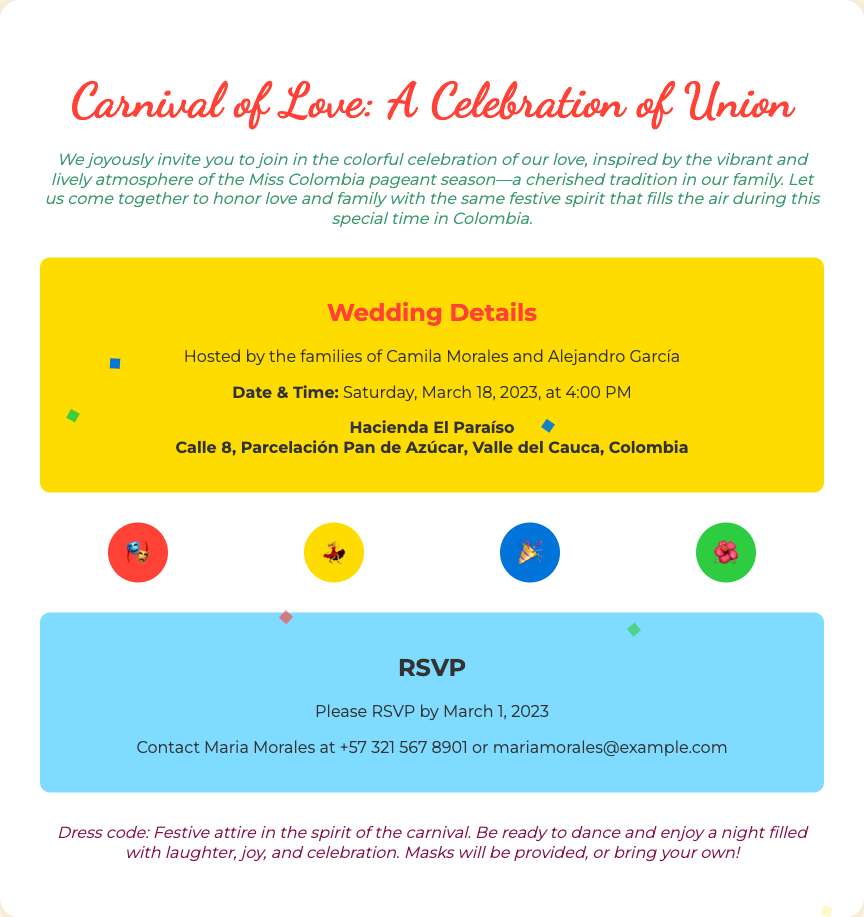What is the title of the wedding invitation? The title can be found at the top of the invitation, representing the theme of the event.
Answer: Carnival of Love: A Celebration of Union Who are the hosts of the wedding? The hosts are mentioned in the details section of the invitation.
Answer: Camila Morales and Alejandro García What is the date of the wedding? The date is specifically listed under the wedding details section.
Answer: Saturday, March 18, 2023 What time is the wedding scheduled to start? The time is included in the wedding details along with the date.
Answer: 4:00 PM Where is the wedding taking place? The location is mentioned in the details section and specifies the venue name and address.
Answer: Hacienda El Paraíso, Calle 8, Parcelación Pan de Azúcar, Valle del Cauca, Colombia What is the RSVP deadline? The RSVP deadline is stated clearly in the RSVP section of the invitation.
Answer: March 1, 2023 Who should be contacted for the RSVP? The contact person for RSVPs is given in the invitation along with contact information.
Answer: Maria Morales What is the dress code for the wedding? The dress code is specified at the end of the invitation, indicating what guests should wear.
Answer: Festive attire in the spirit of the carnival What will be provided for the guests? The invitation mentions something that will be given to the guests, enhancing the festive atmosphere.
Answer: Masks 